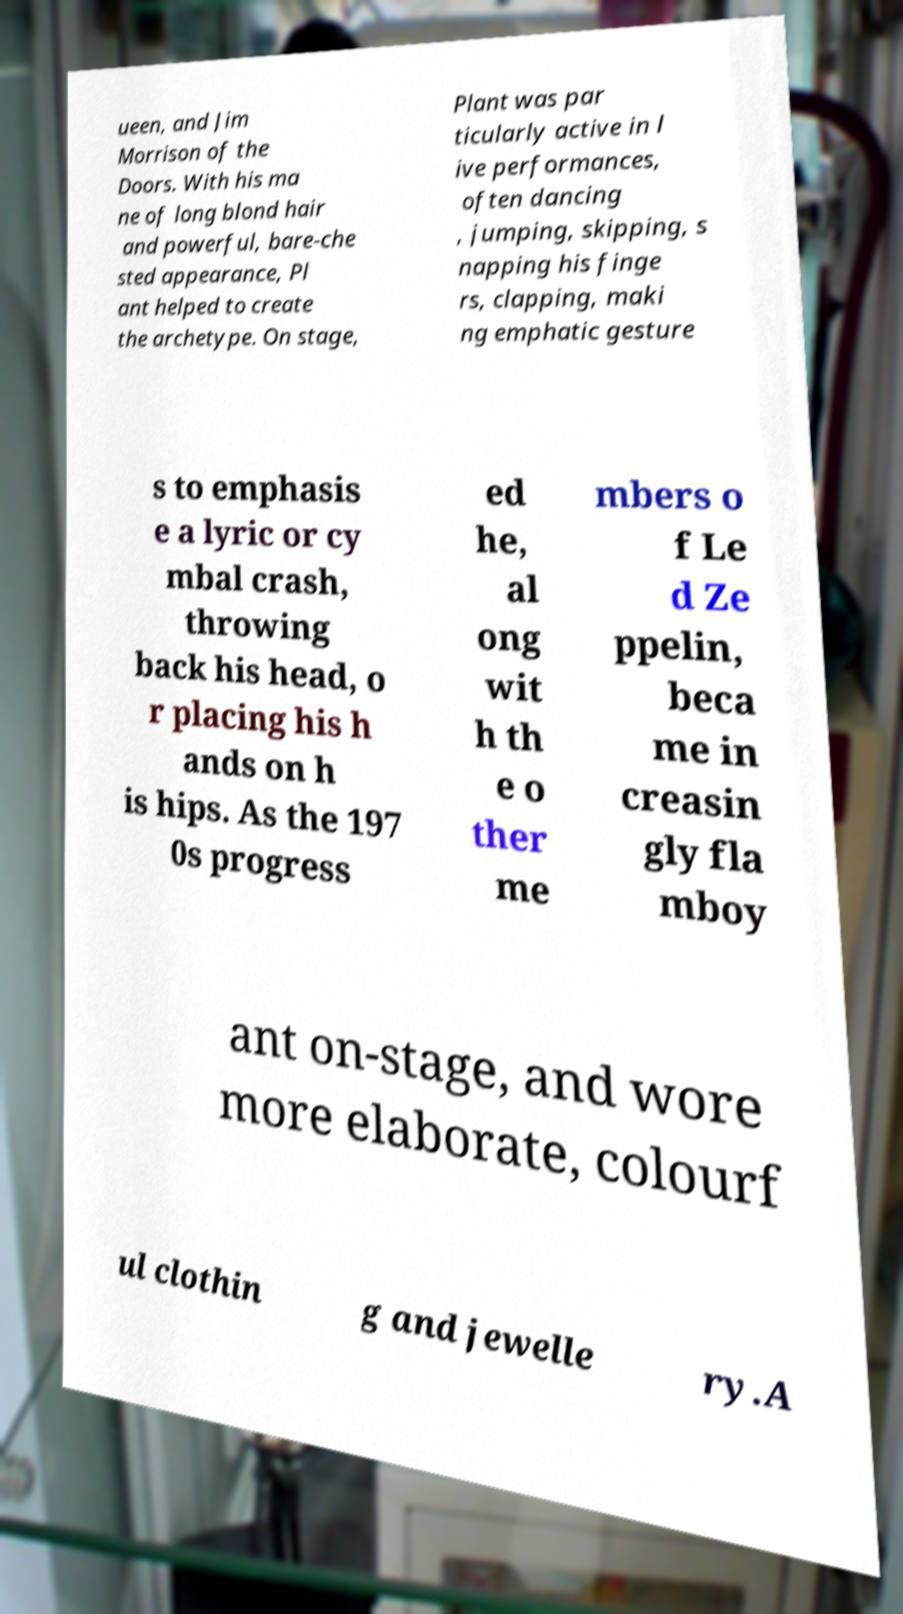Please read and relay the text visible in this image. What does it say? ueen, and Jim Morrison of the Doors. With his ma ne of long blond hair and powerful, bare-che sted appearance, Pl ant helped to create the archetype. On stage, Plant was par ticularly active in l ive performances, often dancing , jumping, skipping, s napping his finge rs, clapping, maki ng emphatic gesture s to emphasis e a lyric or cy mbal crash, throwing back his head, o r placing his h ands on h is hips. As the 197 0s progress ed he, al ong wit h th e o ther me mbers o f Le d Ze ppelin, beca me in creasin gly fla mboy ant on-stage, and wore more elaborate, colourf ul clothin g and jewelle ry.A 